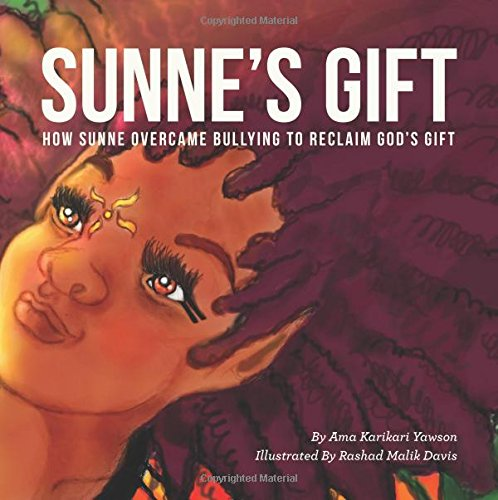Is this a recipe book? No, this book is not a recipe book. It's a children's story that aims to inspire and educate through narrative. 